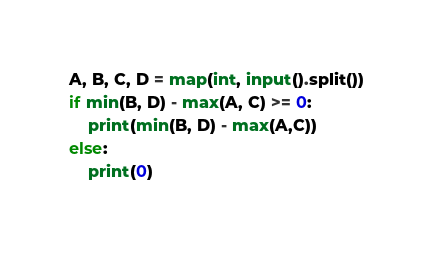<code> <loc_0><loc_0><loc_500><loc_500><_Python_>A, B, C, D = map(int, input().split())
if min(B, D) - max(A, C) >= 0:
    print(min(B, D) - max(A,C))
else:
    print(0)</code> 